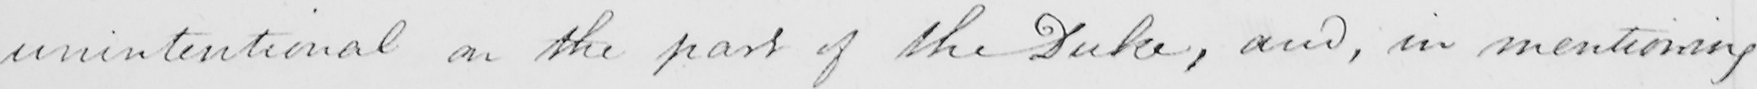Can you tell me what this handwritten text says? unintentional on the part of the Duke , and , in mentioning 